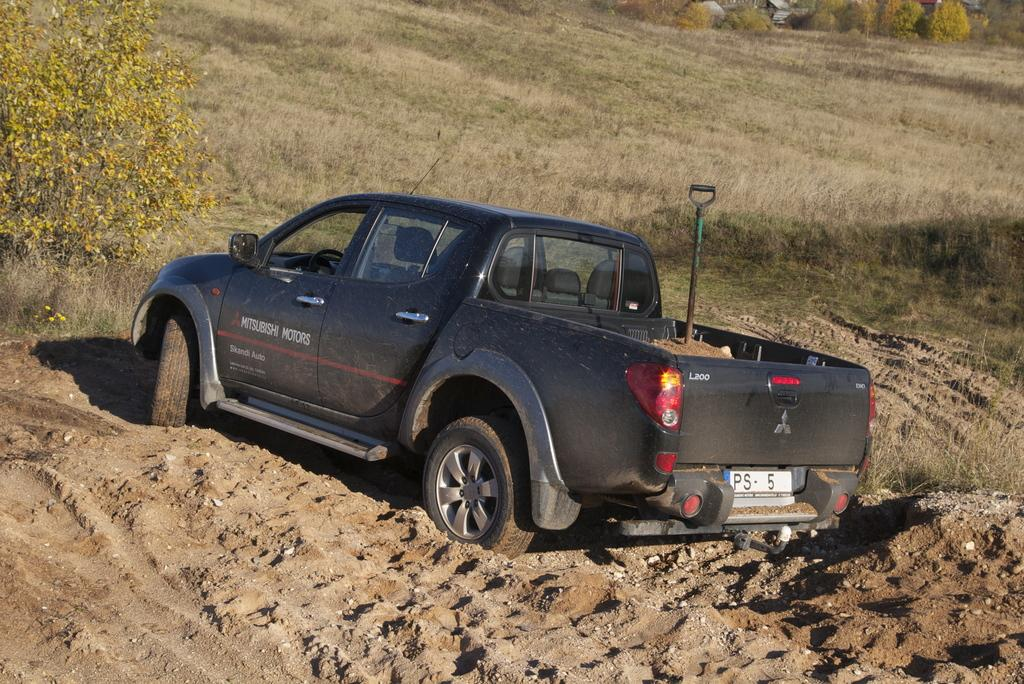What is the main subject of the image? The main subject of the image is a car. Can you describe the car's position in the image? The car is standing on the ground in the image. What is the condition of the ground in the image? The ground is covered with mud in the image. What type of vegetation is visible near the car? There is a grass-covered area beside the car. What can be seen in the background of the image? Trees are visible in the background of the image. Who is having an argument with the car's owner in the image? There is no indication of an argument or a car owner present in the image. 